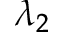Convert formula to latex. <formula><loc_0><loc_0><loc_500><loc_500>\lambda _ { 2 }</formula> 